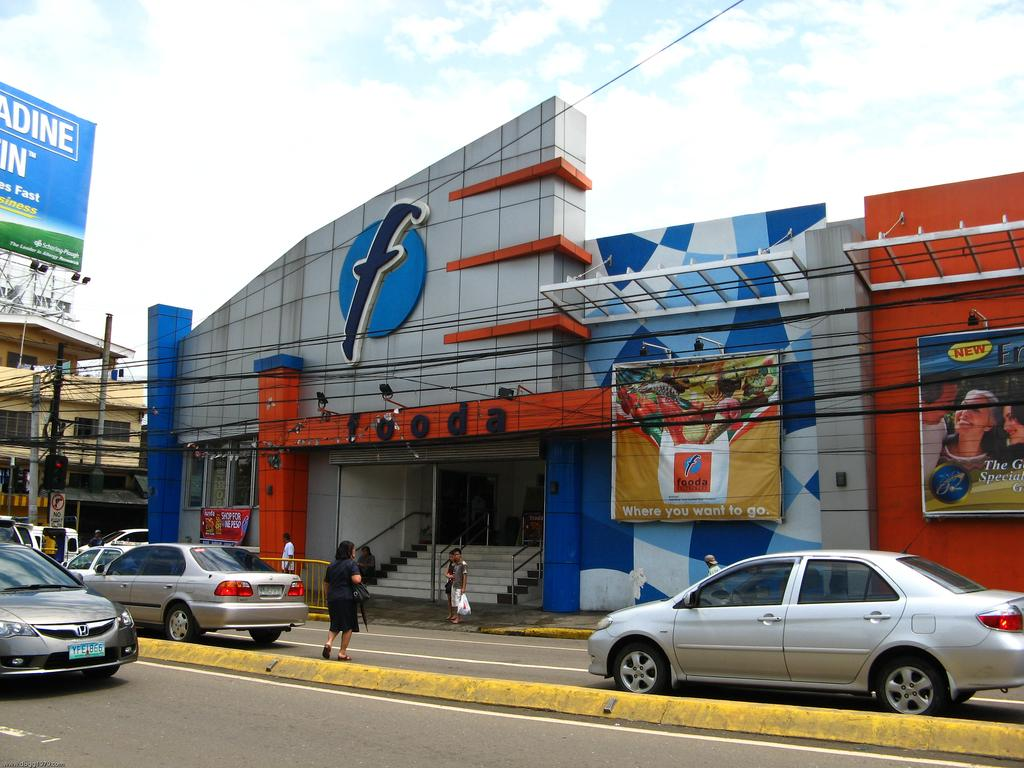Provide a one-sentence caption for the provided image. A store called "fooda" has a huge letter F on the front of it. 